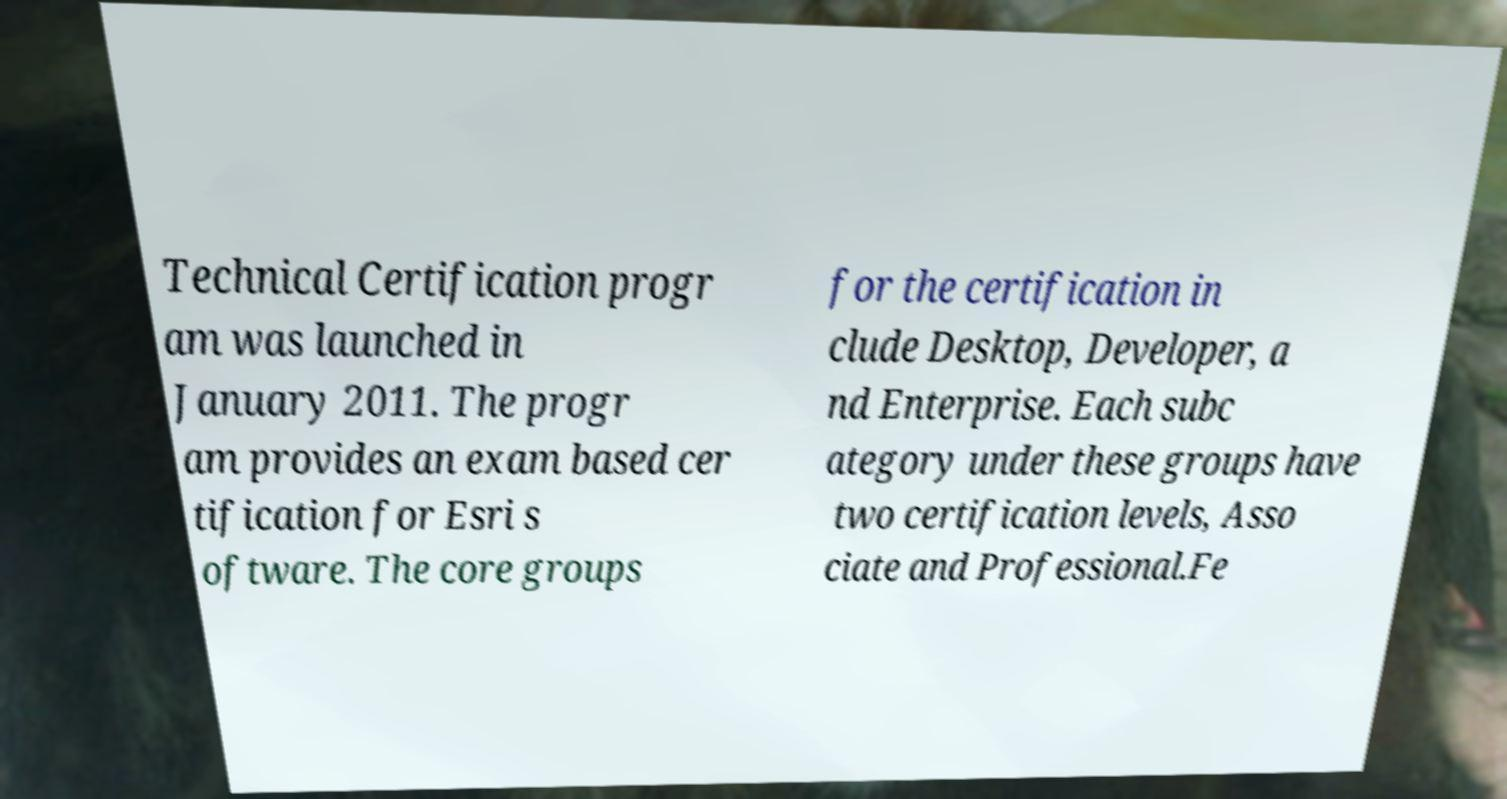Please read and relay the text visible in this image. What does it say? Technical Certification progr am was launched in January 2011. The progr am provides an exam based cer tification for Esri s oftware. The core groups for the certification in clude Desktop, Developer, a nd Enterprise. Each subc ategory under these groups have two certification levels, Asso ciate and Professional.Fe 